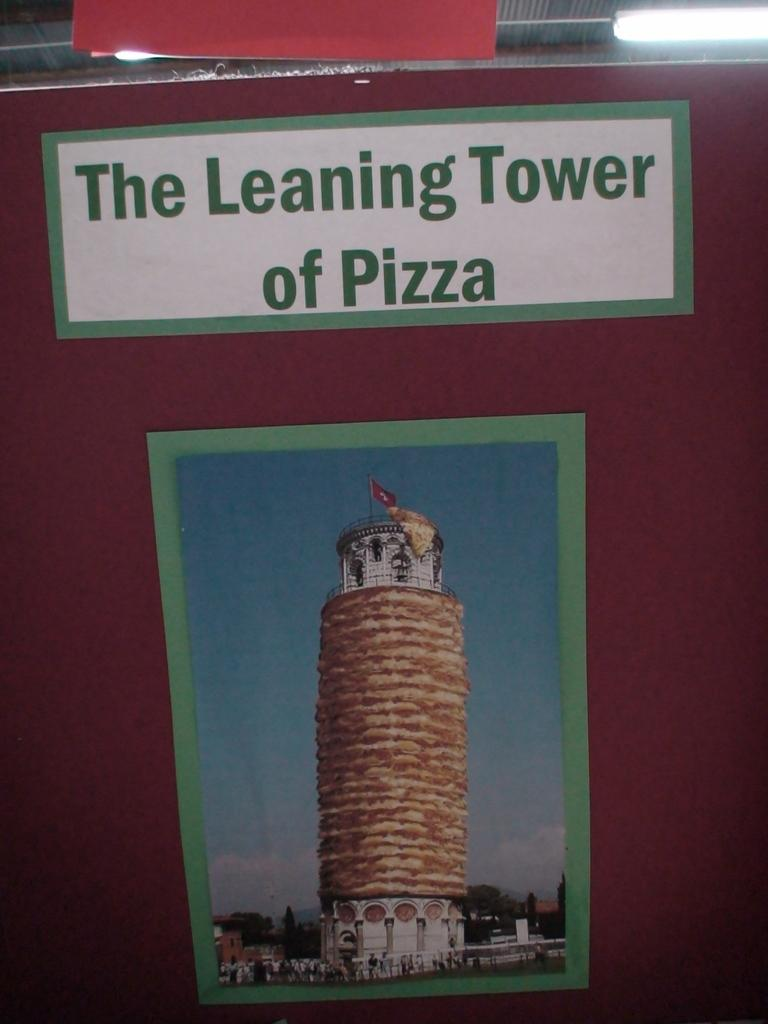<image>
Relay a brief, clear account of the picture shown. A poster of the leaning tower of pisa, but made of pizza. 